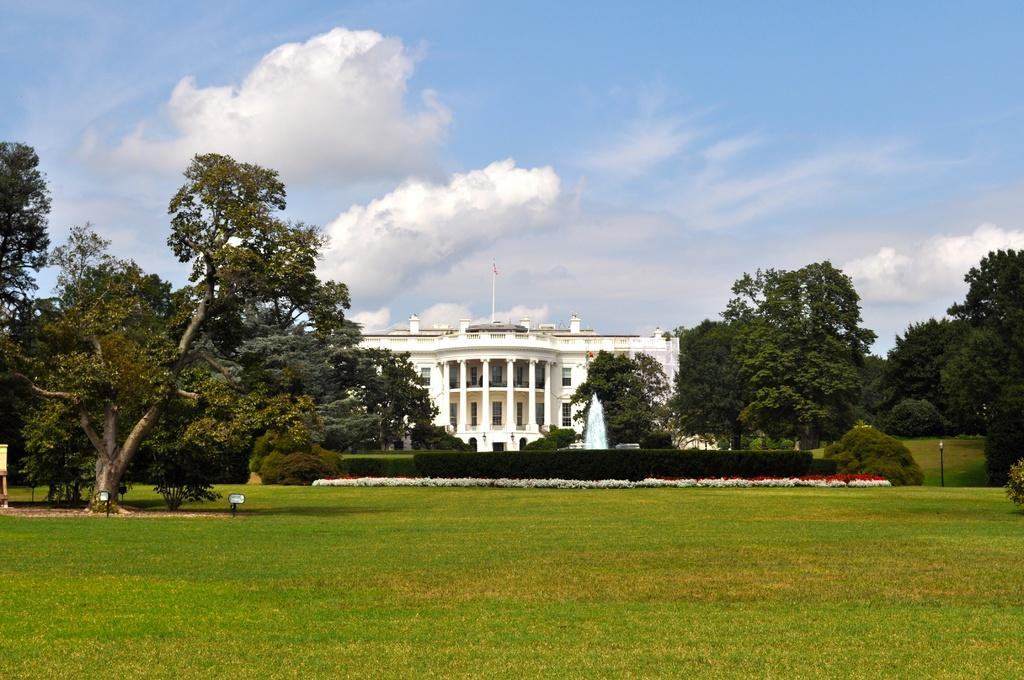What is the color of the building in the image? The building in the image is white. What type of vegetation is present at the bottom of the image? There is green grass at the bottom of the image. Where are the trees located in the image? There are trees on both the left and right sides of the image. What can be seen in the sky at the top of the image? There are clouds visible in the sky at the top of the image. Can you tell me how many basketballs are on the roof of the building in the image? There are no basketballs present on the roof of the building in the image. Is there a bear visible in the image? There is no bear present in the image. 